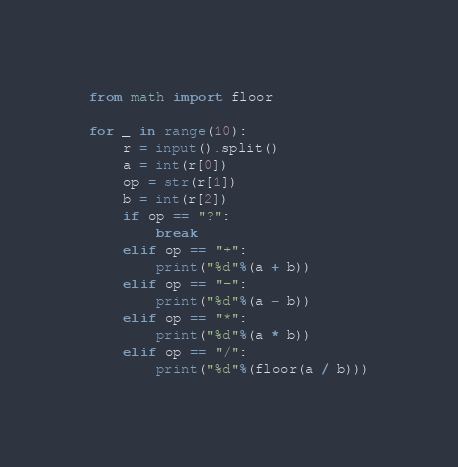<code> <loc_0><loc_0><loc_500><loc_500><_Python_>from math import floor

for _ in range(10):
    r = input().split()
    a = int(r[0])
    op = str(r[1])
    b = int(r[2])
    if op == "?":
        break
    elif op == "+":
        print("%d"%(a + b))
    elif op == "-":
        print("%d"%(a - b))
    elif op == "*":
        print("%d"%(a * b))
    elif op == "/":
        print("%d"%(floor(a / b)))</code> 